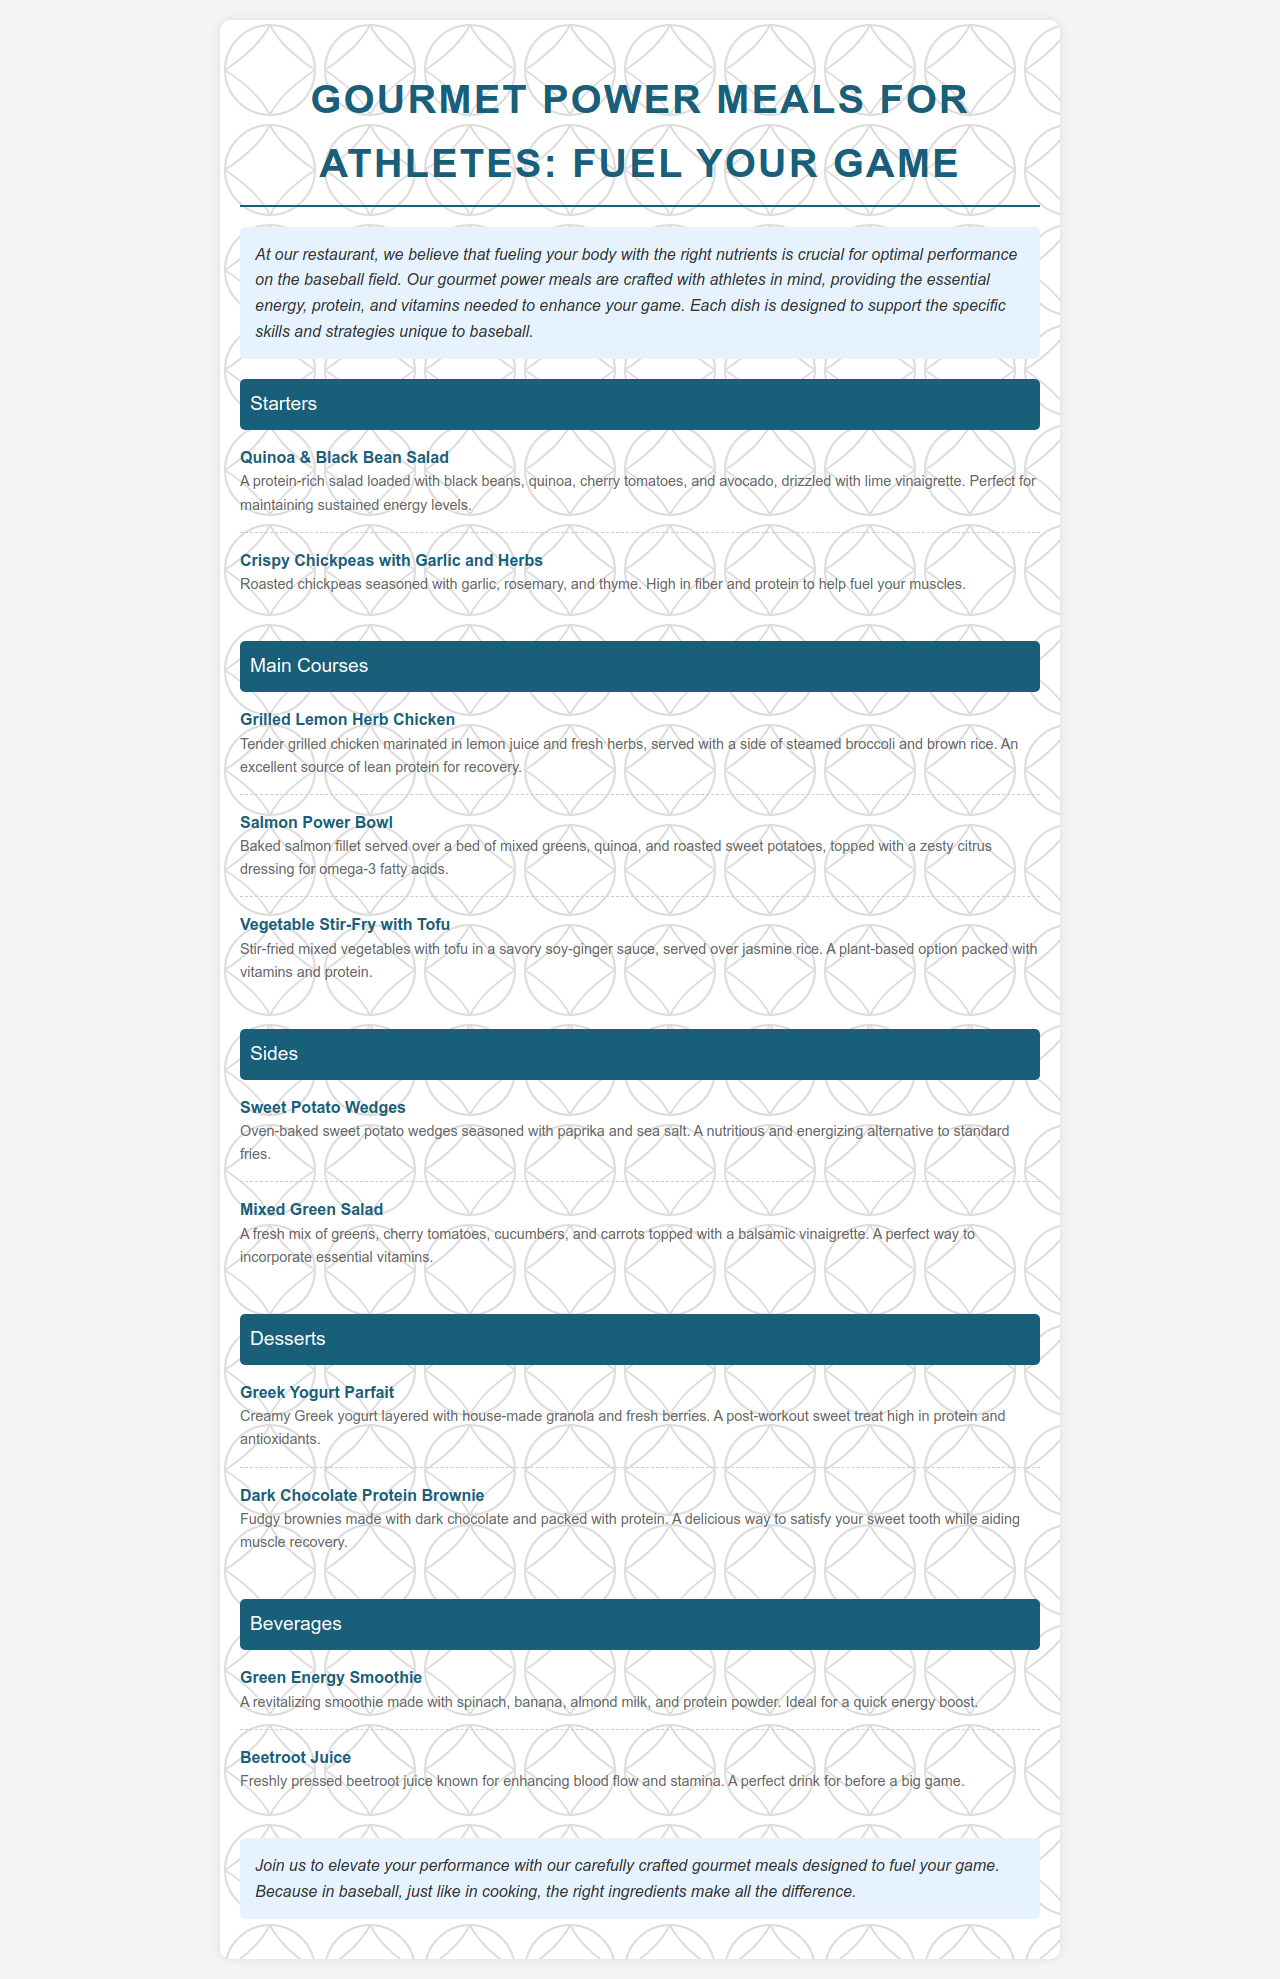What are the main courses available? The main courses listed include Grilled Lemon Herb Chicken, Salmon Power Bowl, and Vegetable Stir-Fry with Tofu.
Answer: Grilled Lemon Herb Chicken, Salmon Power Bowl, Vegetable Stir-Fry with Tofu What is a unique feature of the Quinoa & Black Bean Salad? The salad is described as protein-rich and helps maintain sustained energy levels.
Answer: Protein-rich What dressing is recommended for the Salmon Power Bowl? The Salmon Power Bowl is topped with a zesty citrus dressing.
Answer: Zesty citrus dressing Which dessert is high in protein? The Greek Yogurt Parfait is specifically noted for being high in protein.
Answer: Greek Yogurt Parfait How many beverages are listed on the menu? There are two beverages listed: Green Energy Smoothie and Beetroot Juice.
Answer: Two What is the purpose of the meal descriptions in the menu? The descriptions aim to highlight the essential nutrients and benefits for athletes’ performance.
Answer: Highlight nutrients and benefits Which side dish is an alternative to standard fries? Sweet Potato Wedges are presented as a nutritious alternative.
Answer: Sweet Potato Wedges What is the overall theme of the menu? The theme emphasizes meals specially crafted for athletes to enhance performance.
Answer: Fuel your game 